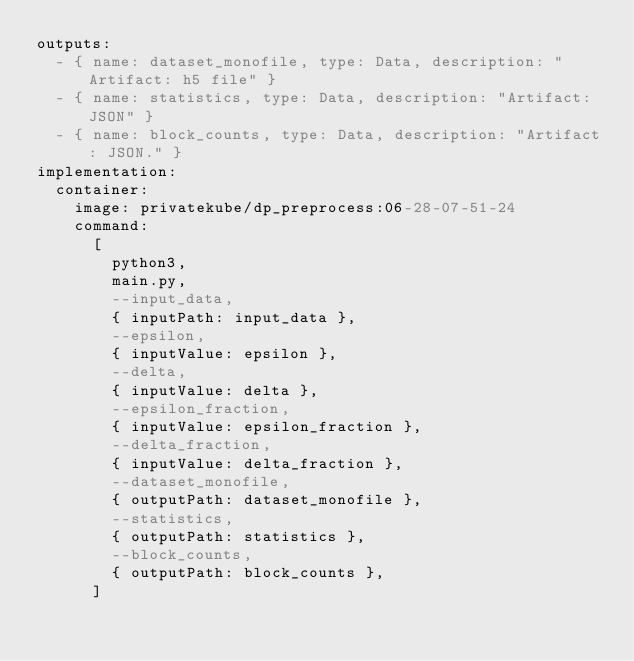Convert code to text. <code><loc_0><loc_0><loc_500><loc_500><_YAML_>outputs:
  - { name: dataset_monofile, type: Data, description: "Artifact: h5 file" }
  - { name: statistics, type: Data, description: "Artifact: JSON" }
  - { name: block_counts, type: Data, description: "Artifact: JSON." }
implementation:
  container:
    image: privatekube/dp_preprocess:06-28-07-51-24
    command:
      [
        python3,
        main.py,
        --input_data,
        { inputPath: input_data },
        --epsilon,
        { inputValue: epsilon },
        --delta,
        { inputValue: delta },
        --epsilon_fraction,
        { inputValue: epsilon_fraction },
        --delta_fraction,
        { inputValue: delta_fraction },
        --dataset_monofile,
        { outputPath: dataset_monofile },
        --statistics,
        { outputPath: statistics },
        --block_counts,
        { outputPath: block_counts },
      ]
</code> 